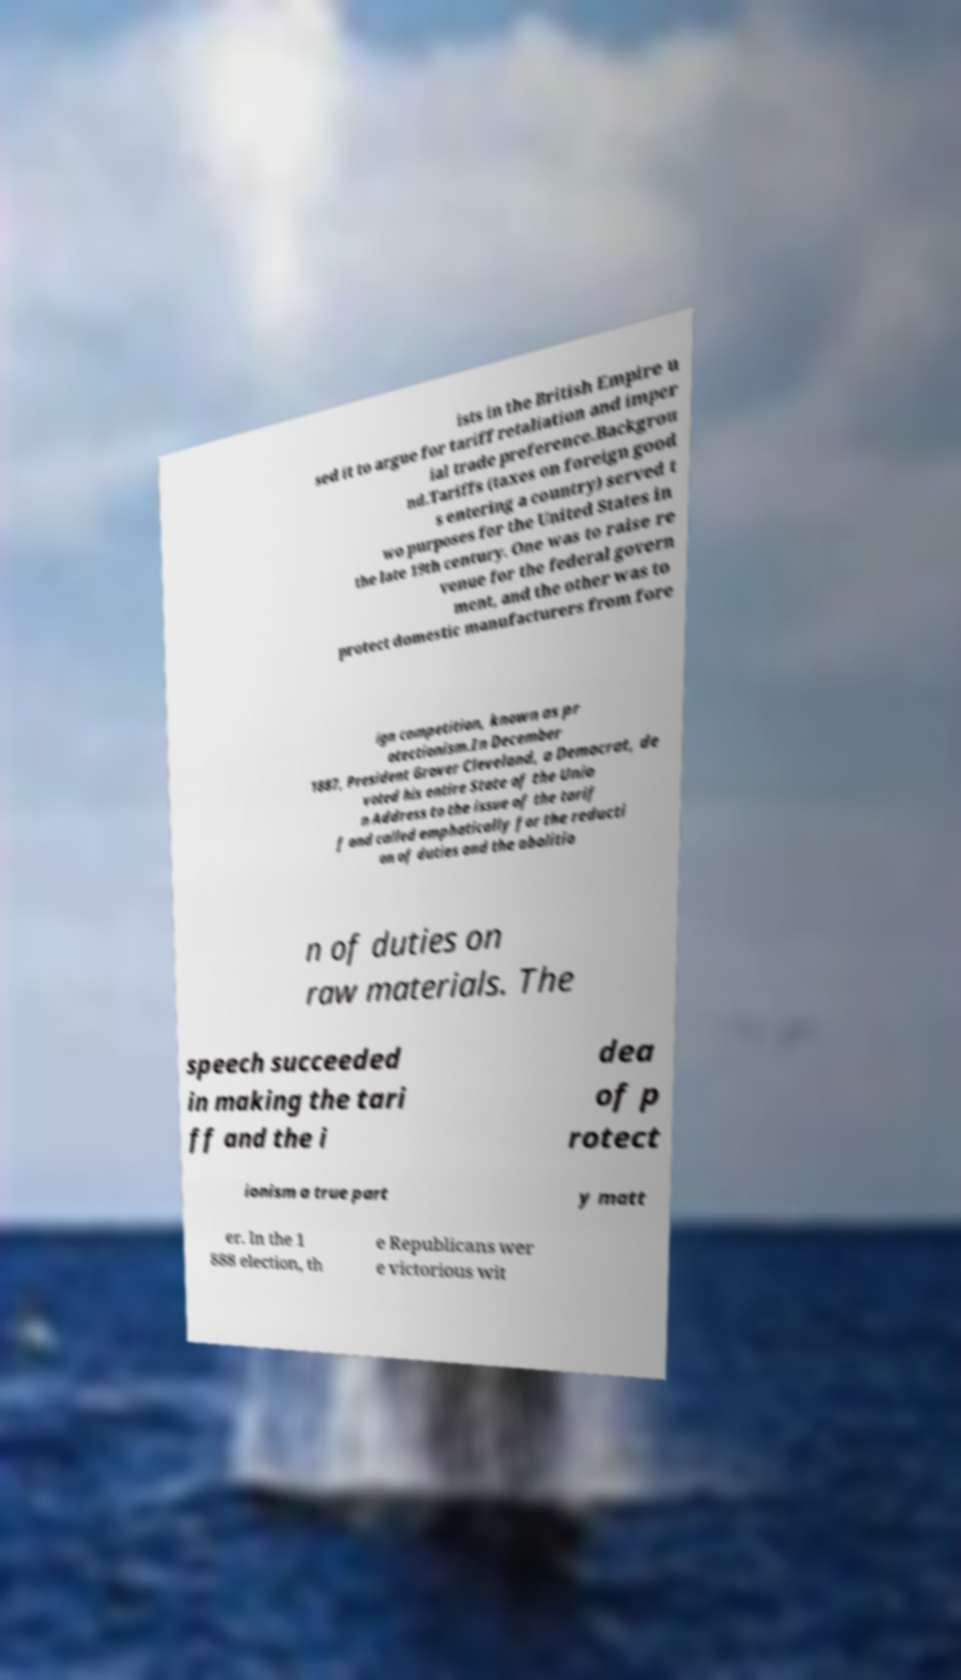Can you accurately transcribe the text from the provided image for me? ists in the British Empire u sed it to argue for tariff retaliation and imper ial trade preference.Backgrou nd.Tariffs (taxes on foreign good s entering a country) served t wo purposes for the United States in the late 19th century. One was to raise re venue for the federal govern ment, and the other was to protect domestic manufacturers from fore ign competition, known as pr otectionism.In December 1887, President Grover Cleveland, a Democrat, de voted his entire State of the Unio n Address to the issue of the tarif f and called emphatically for the reducti on of duties and the abolitio n of duties on raw materials. The speech succeeded in making the tari ff and the i dea of p rotect ionism a true part y matt er. In the 1 888 election, th e Republicans wer e victorious wit 